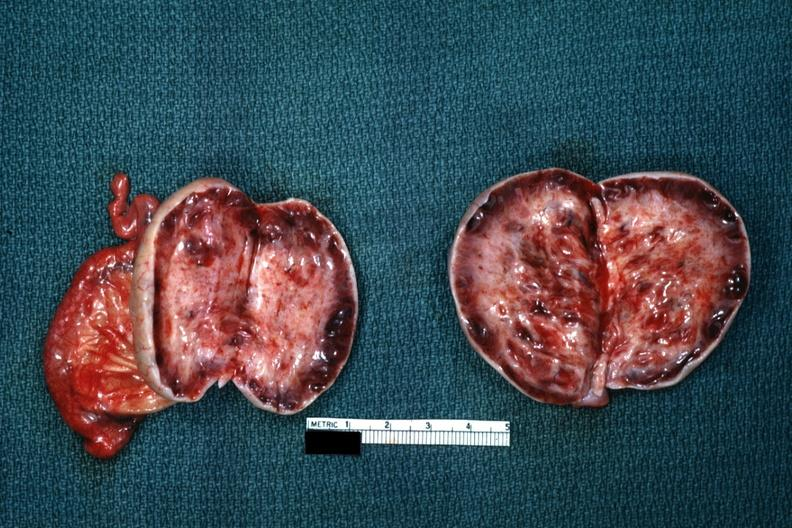s ovary present?
Answer the question using a single word or phrase. Yes 